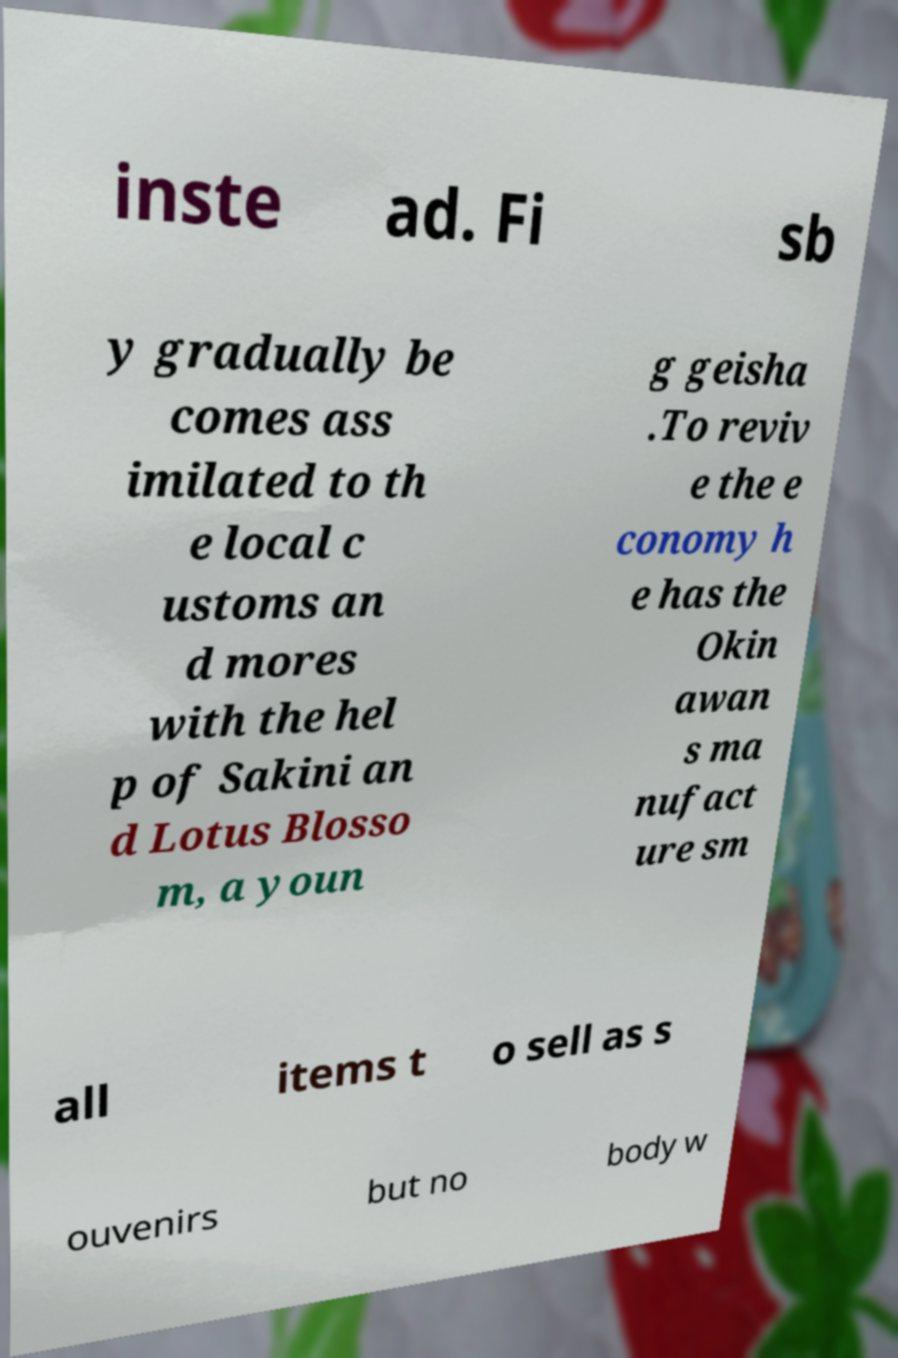Could you extract and type out the text from this image? inste ad. Fi sb y gradually be comes ass imilated to th e local c ustoms an d mores with the hel p of Sakini an d Lotus Blosso m, a youn g geisha .To reviv e the e conomy h e has the Okin awan s ma nufact ure sm all items t o sell as s ouvenirs but no body w 